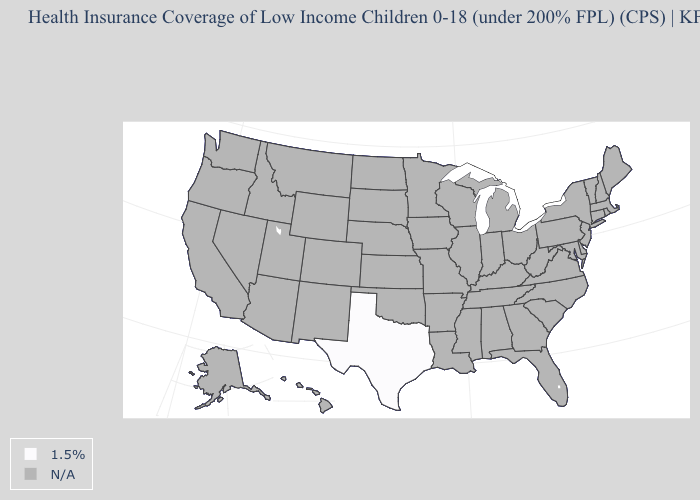Name the states that have a value in the range 1.5%?
Concise answer only. Texas. Name the states that have a value in the range 1.5%?
Keep it brief. Texas. Does the map have missing data?
Keep it brief. Yes. What is the value of Florida?
Be succinct. N/A. Which states have the lowest value in the USA?
Keep it brief. Texas. What is the value of Texas?
Quick response, please. 1.5%. How many symbols are there in the legend?
Answer briefly. 2. Does the first symbol in the legend represent the smallest category?
Quick response, please. Yes. How many symbols are there in the legend?
Answer briefly. 2. What is the value of New Jersey?
Short answer required. N/A. Name the states that have a value in the range N/A?
Answer briefly. Alabama, Alaska, Arizona, Arkansas, California, Colorado, Connecticut, Delaware, Florida, Georgia, Hawaii, Idaho, Illinois, Indiana, Iowa, Kansas, Kentucky, Louisiana, Maine, Maryland, Massachusetts, Michigan, Minnesota, Mississippi, Missouri, Montana, Nebraska, Nevada, New Hampshire, New Jersey, New Mexico, New York, North Carolina, North Dakota, Ohio, Oklahoma, Oregon, Pennsylvania, Rhode Island, South Carolina, South Dakota, Tennessee, Utah, Vermont, Virginia, Washington, West Virginia, Wisconsin, Wyoming. What is the value of Maine?
Give a very brief answer. N/A. Is the legend a continuous bar?
Be succinct. No. 